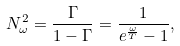Convert formula to latex. <formula><loc_0><loc_0><loc_500><loc_500>N _ { \omega } ^ { 2 } = \frac { \Gamma } { 1 - \Gamma } = \frac { 1 } { e ^ { \frac { \omega } { T } } - 1 } ,</formula> 